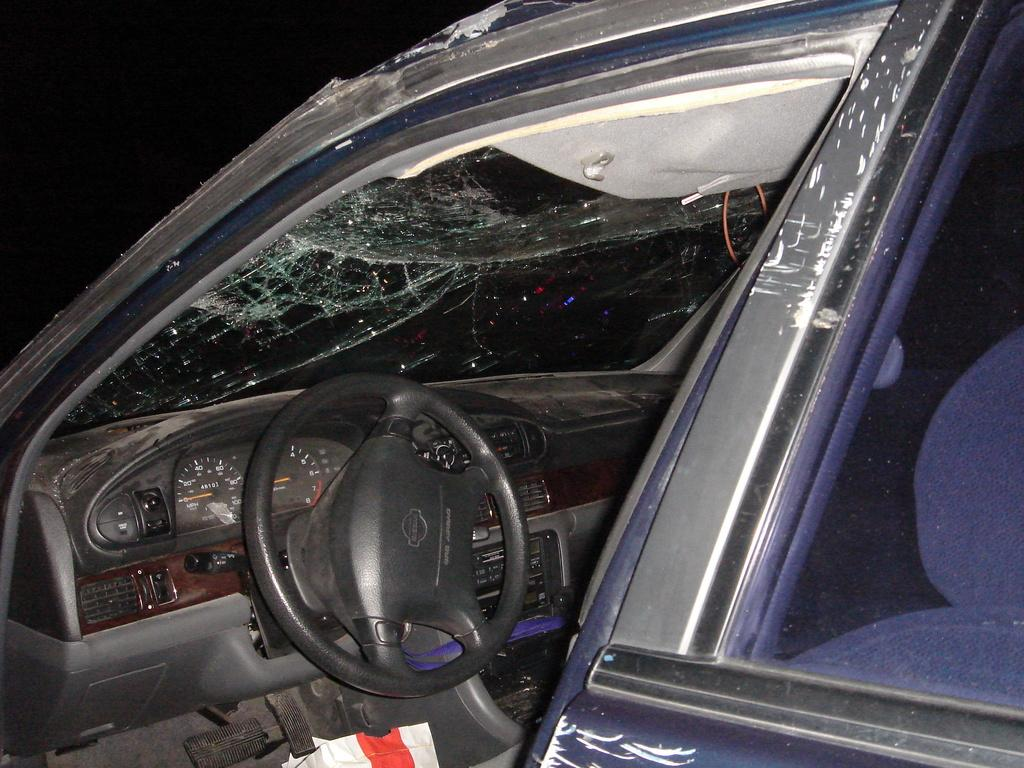What is the main subject of the picture? The main subject of the picture is a car. What is the condition of the car's windshield glass? The windshield glass of the car is broken. What part of the car can be seen in the image? The steering of the car is visible. Where are the speed indicating meters located in the car? The speed indicating meters are present on the left side of the car. What type of furniture can be seen in the car's trunk in the image? There is no furniture visible in the image, as it only shows a car with a broken windshield glass, visible steering, and speed indicating meters on the left side. 